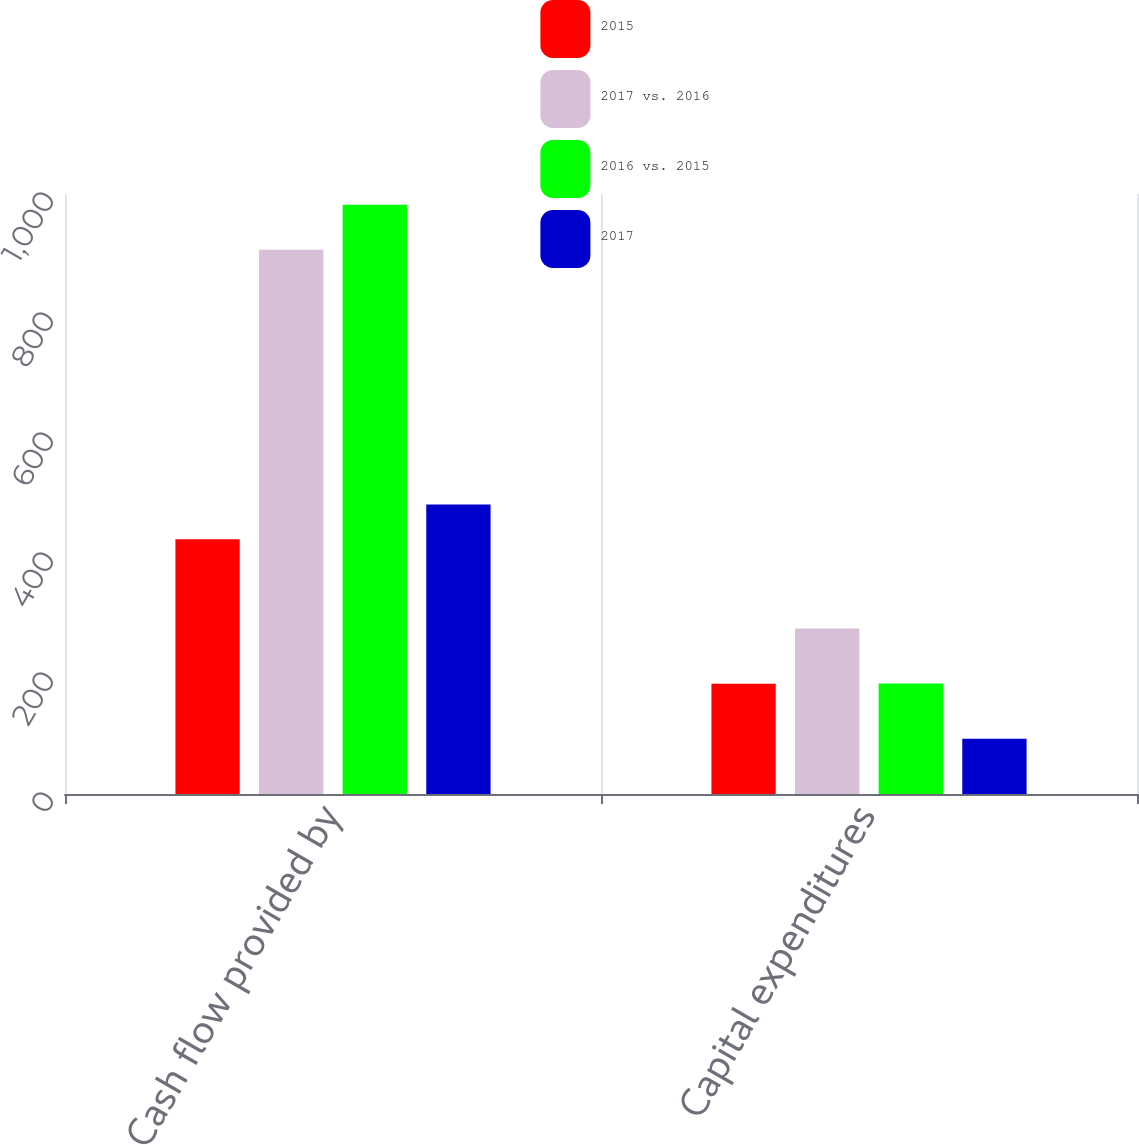Convert chart to OTSL. <chart><loc_0><loc_0><loc_500><loc_500><stacked_bar_chart><ecel><fcel>Cash flow provided by<fcel>Capital expenditures<nl><fcel>2015<fcel>424.4<fcel>183.8<nl><fcel>2017 vs. 2016<fcel>906.9<fcel>275.7<nl><fcel>2016 vs. 2015<fcel>982.1<fcel>184<nl><fcel>2017<fcel>482.5<fcel>91.9<nl></chart> 